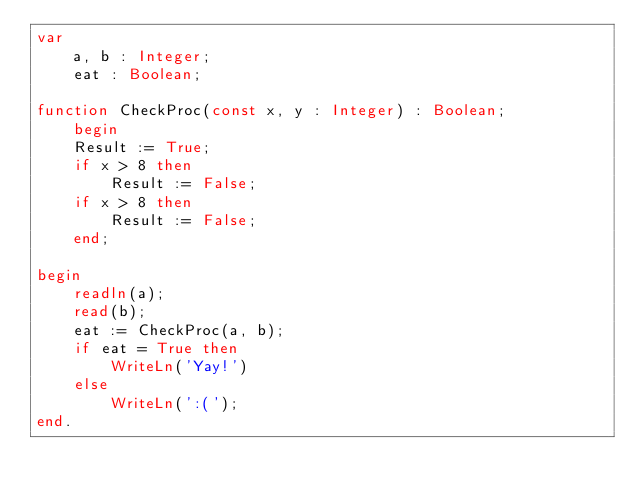<code> <loc_0><loc_0><loc_500><loc_500><_Pascal_>var
	a, b : Integer;
	eat : Boolean;
	
function CheckProc(const x, y : Integer) : Boolean;
	begin
	Result := True;
	if x > 8 then
		Result := False;
	if x > 8 then
		Result := False;
	end;
	
begin
	readln(a);
	read(b);
	eat := CheckProc(a, b);
	if eat = True then
		WriteLn('Yay!')
	else
		WriteLn(':(');
end.</code> 